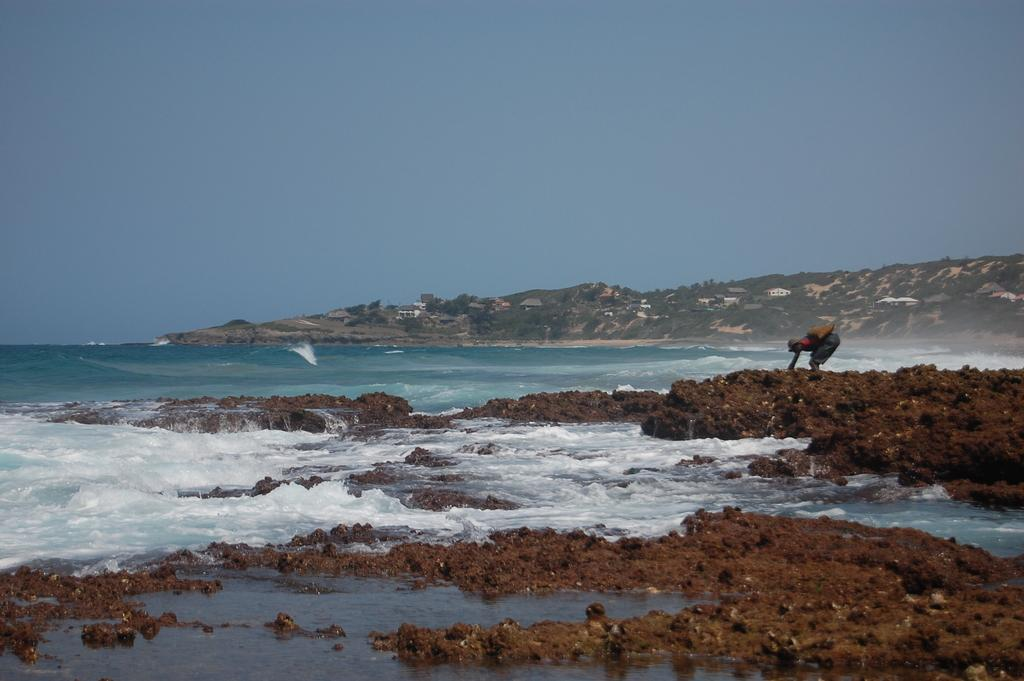What is the person in the image standing on? The person is standing on the mud. What else can be seen in the image besides the person? Water is visible in the image, and there are trees, houses, and the sky in the background. What type of throat-soothing remedy can be seen in the image? There is no throat-soothing remedy present in the image. What type of celery is growing in the background of the image? There is no celery visible in the image; only trees and houses are present in the background. 